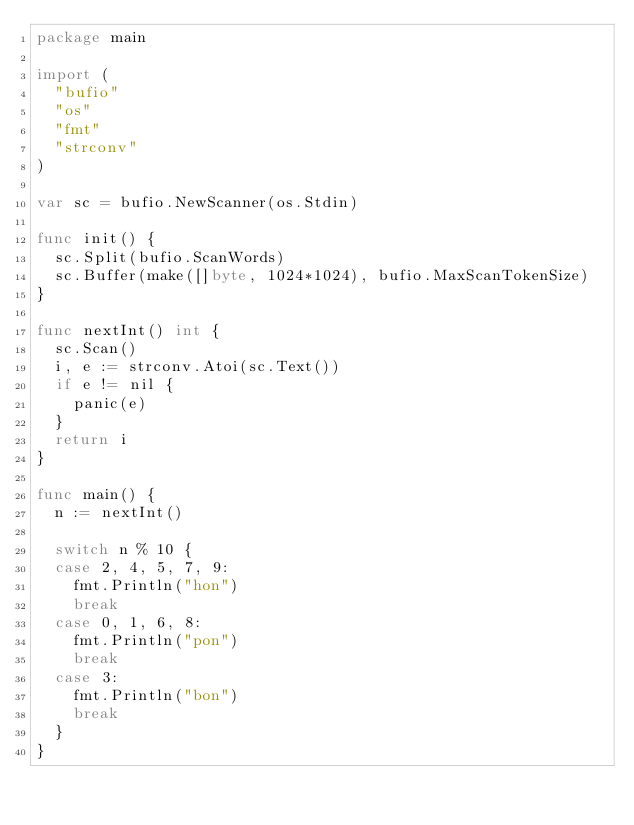<code> <loc_0><loc_0><loc_500><loc_500><_Go_>package main

import (
	"bufio"
	"os"
	"fmt"
	"strconv"
)

var sc = bufio.NewScanner(os.Stdin)

func init() {
	sc.Split(bufio.ScanWords)
	sc.Buffer(make([]byte, 1024*1024), bufio.MaxScanTokenSize)
}

func nextInt() int {
	sc.Scan()
	i, e := strconv.Atoi(sc.Text())
	if e != nil {
		panic(e)
	}
	return i
}

func main() {
	n := nextInt()

	switch n % 10 {
	case 2, 4, 5, 7, 9:
		fmt.Println("hon")
		break
	case 0, 1, 6, 8:
		fmt.Println("pon")
		break
	case 3:
		fmt.Println("bon")
		break
	}
}
</code> 